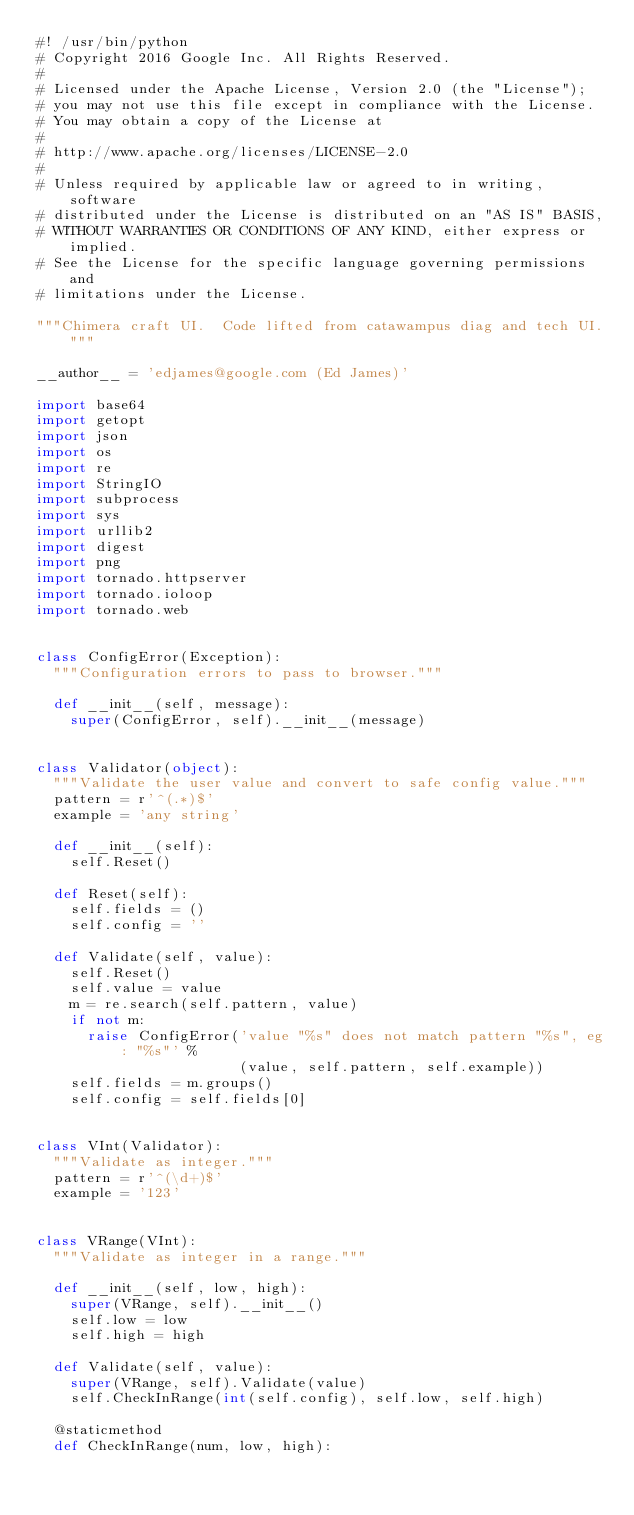Convert code to text. <code><loc_0><loc_0><loc_500><loc_500><_Python_>#! /usr/bin/python
# Copyright 2016 Google Inc. All Rights Reserved.
#
# Licensed under the Apache License, Version 2.0 (the "License");
# you may not use this file except in compliance with the License.
# You may obtain a copy of the License at
#
# http://www.apache.org/licenses/LICENSE-2.0
#
# Unless required by applicable law or agreed to in writing, software
# distributed under the License is distributed on an "AS IS" BASIS,
# WITHOUT WARRANTIES OR CONDITIONS OF ANY KIND, either express or implied.
# See the License for the specific language governing permissions and
# limitations under the License.

"""Chimera craft UI.  Code lifted from catawampus diag and tech UI."""

__author__ = 'edjames@google.com (Ed James)'

import base64
import getopt
import json
import os
import re
import StringIO
import subprocess
import sys
import urllib2
import digest
import png
import tornado.httpserver
import tornado.ioloop
import tornado.web


class ConfigError(Exception):
  """Configuration errors to pass to browser."""

  def __init__(self, message):
    super(ConfigError, self).__init__(message)


class Validator(object):
  """Validate the user value and convert to safe config value."""
  pattern = r'^(.*)$'
  example = 'any string'

  def __init__(self):
    self.Reset()

  def Reset(self):
    self.fields = ()
    self.config = ''

  def Validate(self, value):
    self.Reset()
    self.value = value
    m = re.search(self.pattern, value)
    if not m:
      raise ConfigError('value "%s" does not match pattern "%s", eg: "%s"' %
                        (value, self.pattern, self.example))
    self.fields = m.groups()
    self.config = self.fields[0]


class VInt(Validator):
  """Validate as integer."""
  pattern = r'^(\d+)$'
  example = '123'


class VRange(VInt):
  """Validate as integer in a range."""

  def __init__(self, low, high):
    super(VRange, self).__init__()
    self.low = low
    self.high = high

  def Validate(self, value):
    super(VRange, self).Validate(value)
    self.CheckInRange(int(self.config), self.low, self.high)

  @staticmethod
  def CheckInRange(num, low, high):</code> 